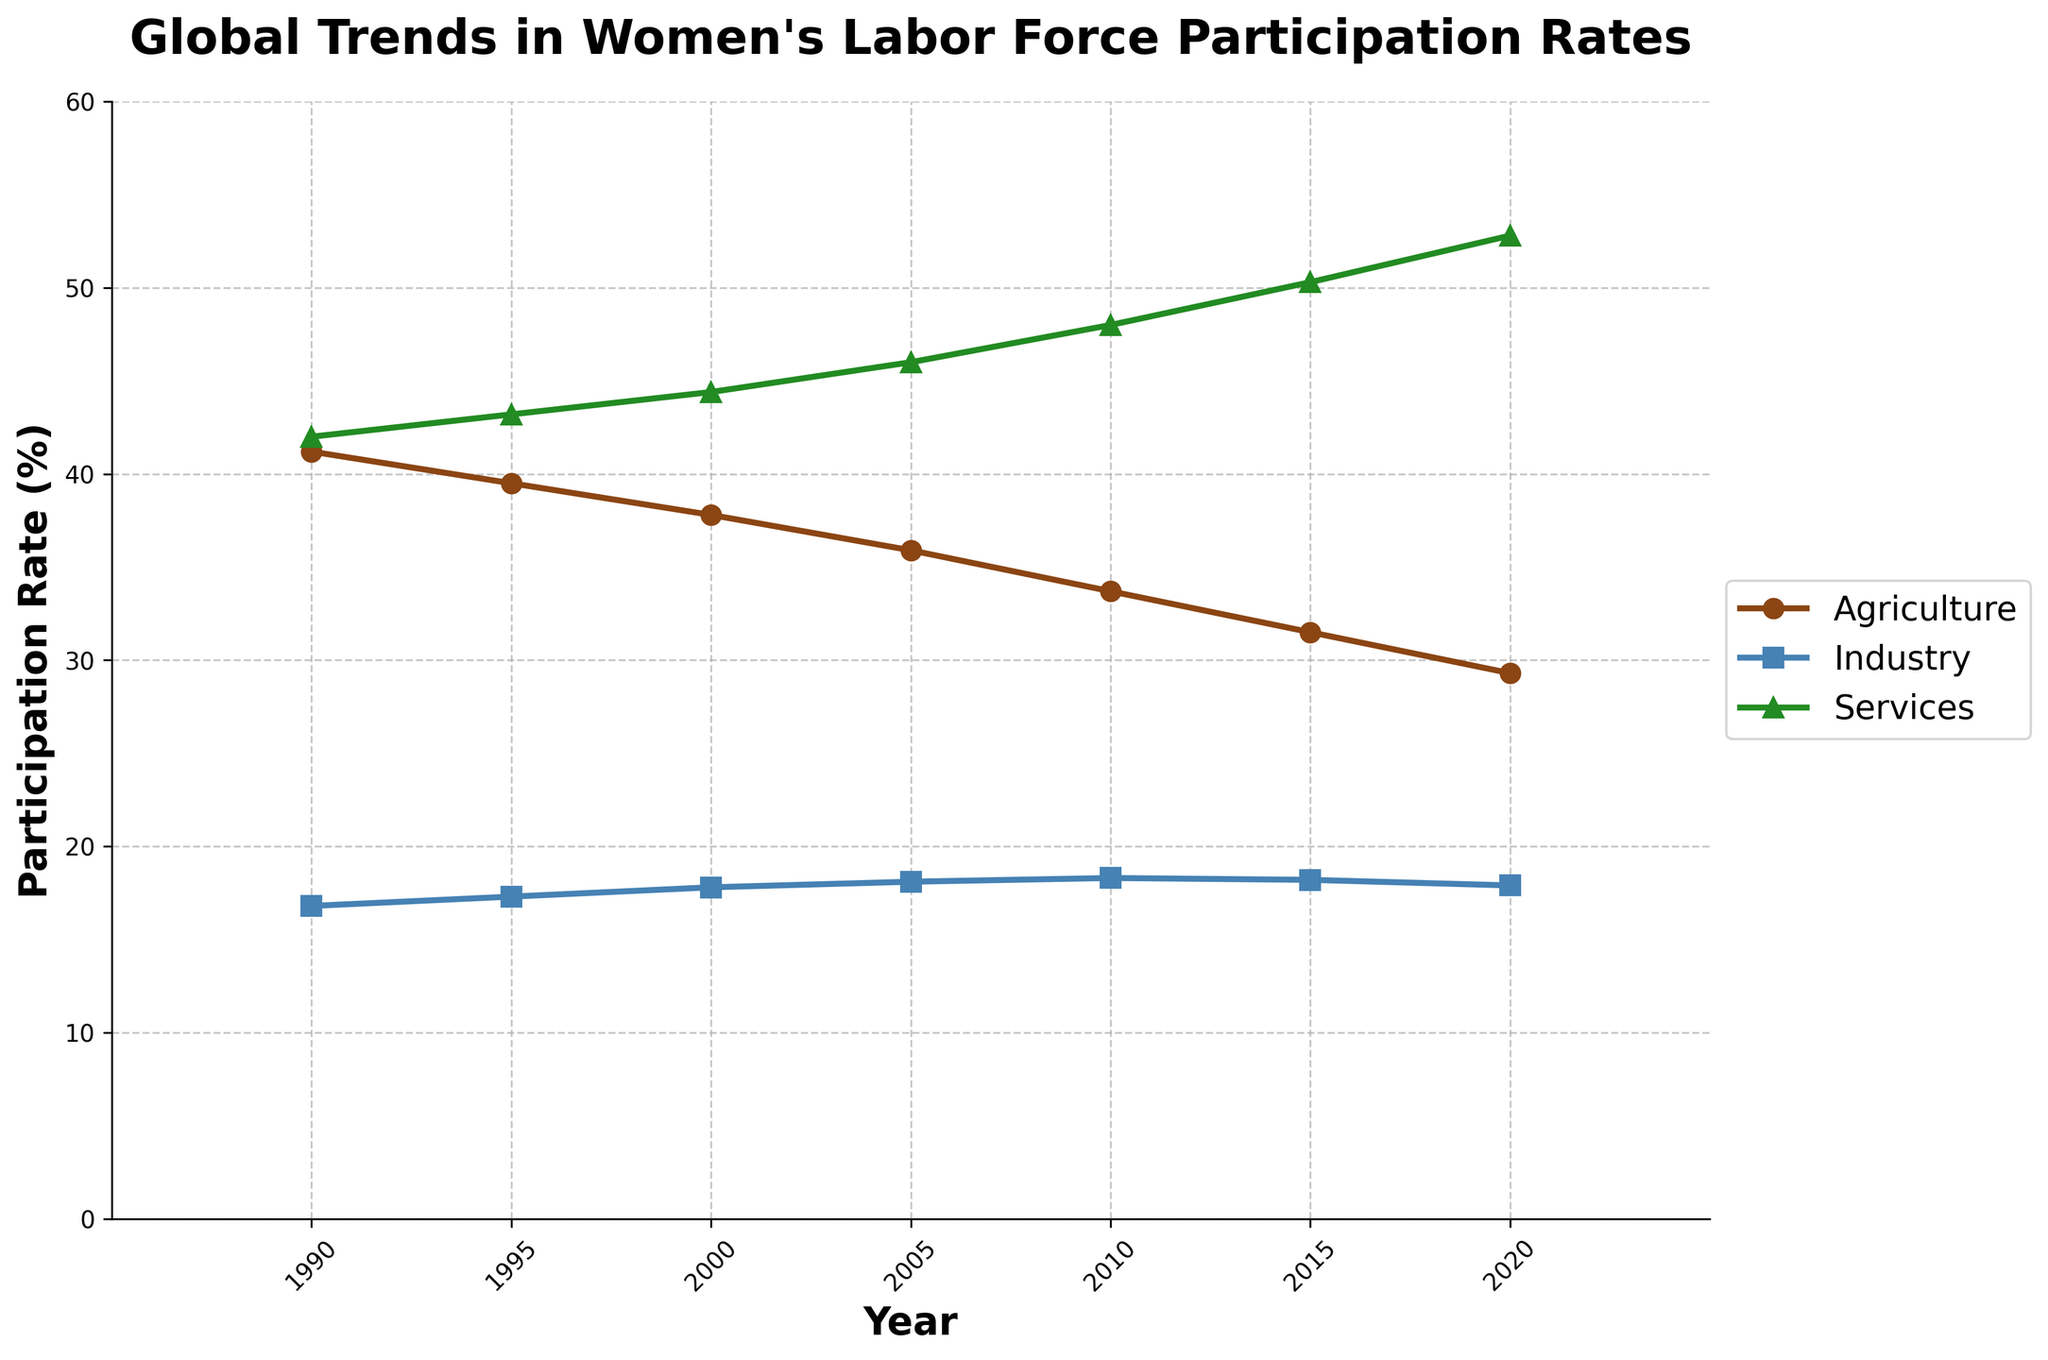What year did the percentage of women in the agriculture sector fall below 35%? The figure shows the women's participation rate in agriculture over the years. According to the line for agriculture, it fell below 35% around 2005.
Answer: 2005 Which sector saw the greatest increase in women's labor force participation over the 30-year period? By observing the trend lines in the figure, the services sector shows the most significant increase in women's participation rate from 42.0% in 1990 to 52.8% in 2020.
Answer: Services What is the difference in the participation rate between the industry and agriculture sectors in 2020? Referring to the endpoints of the lines for the respective sectors in 2020, the industry sector is at 17.9% and agriculture is at 29.3%. The difference is 29.3 - 17.9 = 11.4%.
Answer: 11.4% In which year did the percentage of women in the services sector first exceed 45%? Looking at the trend line for the services sector, it exceeded 45% between 2005 and 2010. The specific value in 2005 is 46.0%, so it first exceeded 45% in 2005.
Answer: 2005 How does the participation rate of women in the agriculture sector in 1990 compare to that in 2020? By observing the starting and ending points of the agriculture line, it starts at 41.2% in 1990 and ends at 29.3% in 2020. The participation rate in the agriculture sector has decreased.
Answer: Decreased Which sector had the most stable participation rate over the 30 years? Examining the trends, the industry sector shows the smallest variation in participation rate, relatively stable compared to agriculture and services.
Answer: Industry What is the average participation rate of women in the agriculture sector from 1990 to 2020? Add the percentages for each year and divide by the number of years (41.2 + 39.5 + 37.8 + 35.9 + 33.7 + 31.5 + 29.3) / 7 = 35.55%.
Answer: 35.55% Which year shows the highest participation rate of women in the services sector? Observing the line for the services sector, the highest percentage is at the endpoint in 2020 with 52.8%.
Answer: 2020 What is the combined participation rate for the industry and services sectors in 2000? According to the figure, in 2000, the industry sector is at 17.8% and the services sector is at 44.4%. The combined rate is 17.8 + 44.4 = 62.2%.
Answer: 62.2% How did the participation rate of women in agriculture change from 2015 to 2020? The figure shows the agriculture participation rate was 31.5% in 2015 and dropped to 29.3% in 2020. This represents a decrease of 31.5 - 29.3 = 2.2%.
Answer: Decreased by 2.2% 